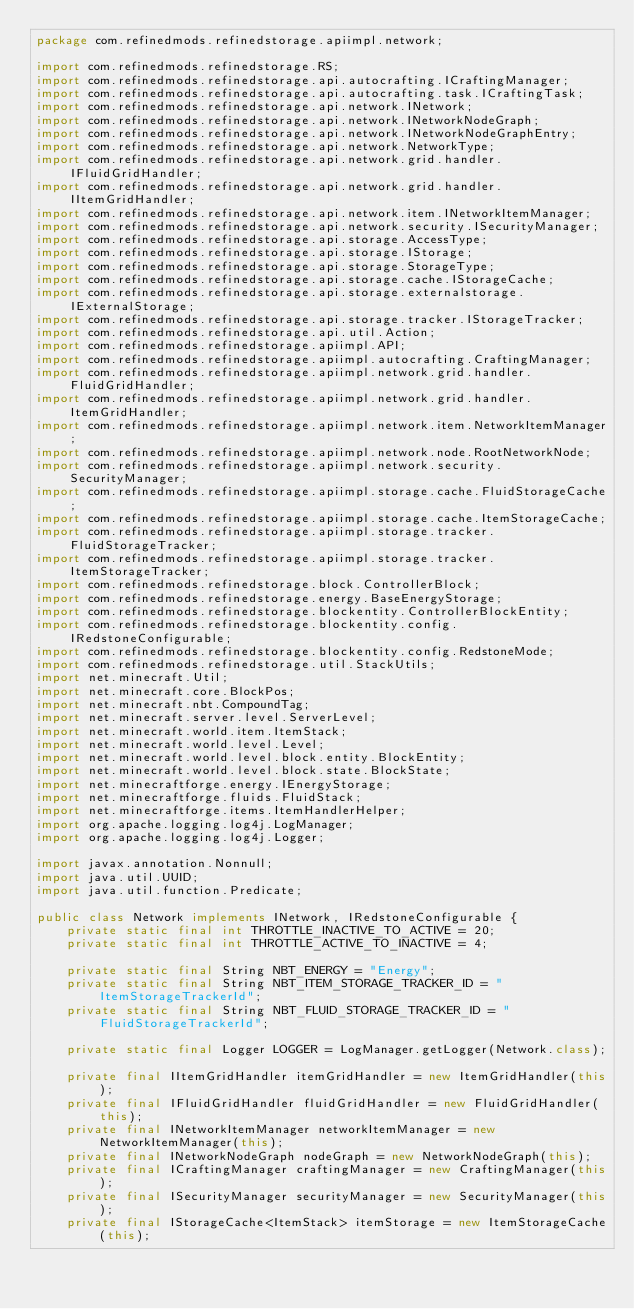<code> <loc_0><loc_0><loc_500><loc_500><_Java_>package com.refinedmods.refinedstorage.apiimpl.network;

import com.refinedmods.refinedstorage.RS;
import com.refinedmods.refinedstorage.api.autocrafting.ICraftingManager;
import com.refinedmods.refinedstorage.api.autocrafting.task.ICraftingTask;
import com.refinedmods.refinedstorage.api.network.INetwork;
import com.refinedmods.refinedstorage.api.network.INetworkNodeGraph;
import com.refinedmods.refinedstorage.api.network.INetworkNodeGraphEntry;
import com.refinedmods.refinedstorage.api.network.NetworkType;
import com.refinedmods.refinedstorage.api.network.grid.handler.IFluidGridHandler;
import com.refinedmods.refinedstorage.api.network.grid.handler.IItemGridHandler;
import com.refinedmods.refinedstorage.api.network.item.INetworkItemManager;
import com.refinedmods.refinedstorage.api.network.security.ISecurityManager;
import com.refinedmods.refinedstorage.api.storage.AccessType;
import com.refinedmods.refinedstorage.api.storage.IStorage;
import com.refinedmods.refinedstorage.api.storage.StorageType;
import com.refinedmods.refinedstorage.api.storage.cache.IStorageCache;
import com.refinedmods.refinedstorage.api.storage.externalstorage.IExternalStorage;
import com.refinedmods.refinedstorage.api.storage.tracker.IStorageTracker;
import com.refinedmods.refinedstorage.api.util.Action;
import com.refinedmods.refinedstorage.apiimpl.API;
import com.refinedmods.refinedstorage.apiimpl.autocrafting.CraftingManager;
import com.refinedmods.refinedstorage.apiimpl.network.grid.handler.FluidGridHandler;
import com.refinedmods.refinedstorage.apiimpl.network.grid.handler.ItemGridHandler;
import com.refinedmods.refinedstorage.apiimpl.network.item.NetworkItemManager;
import com.refinedmods.refinedstorage.apiimpl.network.node.RootNetworkNode;
import com.refinedmods.refinedstorage.apiimpl.network.security.SecurityManager;
import com.refinedmods.refinedstorage.apiimpl.storage.cache.FluidStorageCache;
import com.refinedmods.refinedstorage.apiimpl.storage.cache.ItemStorageCache;
import com.refinedmods.refinedstorage.apiimpl.storage.tracker.FluidStorageTracker;
import com.refinedmods.refinedstorage.apiimpl.storage.tracker.ItemStorageTracker;
import com.refinedmods.refinedstorage.block.ControllerBlock;
import com.refinedmods.refinedstorage.energy.BaseEnergyStorage;
import com.refinedmods.refinedstorage.blockentity.ControllerBlockEntity;
import com.refinedmods.refinedstorage.blockentity.config.IRedstoneConfigurable;
import com.refinedmods.refinedstorage.blockentity.config.RedstoneMode;
import com.refinedmods.refinedstorage.util.StackUtils;
import net.minecraft.Util;
import net.minecraft.core.BlockPos;
import net.minecraft.nbt.CompoundTag;
import net.minecraft.server.level.ServerLevel;
import net.minecraft.world.item.ItemStack;
import net.minecraft.world.level.Level;
import net.minecraft.world.level.block.entity.BlockEntity;
import net.minecraft.world.level.block.state.BlockState;
import net.minecraftforge.energy.IEnergyStorage;
import net.minecraftforge.fluids.FluidStack;
import net.minecraftforge.items.ItemHandlerHelper;
import org.apache.logging.log4j.LogManager;
import org.apache.logging.log4j.Logger;

import javax.annotation.Nonnull;
import java.util.UUID;
import java.util.function.Predicate;

public class Network implements INetwork, IRedstoneConfigurable {
    private static final int THROTTLE_INACTIVE_TO_ACTIVE = 20;
    private static final int THROTTLE_ACTIVE_TO_INACTIVE = 4;

    private static final String NBT_ENERGY = "Energy";
    private static final String NBT_ITEM_STORAGE_TRACKER_ID = "ItemStorageTrackerId";
    private static final String NBT_FLUID_STORAGE_TRACKER_ID = "FluidStorageTrackerId";

    private static final Logger LOGGER = LogManager.getLogger(Network.class);

    private final IItemGridHandler itemGridHandler = new ItemGridHandler(this);
    private final IFluidGridHandler fluidGridHandler = new FluidGridHandler(this);
    private final INetworkItemManager networkItemManager = new NetworkItemManager(this);
    private final INetworkNodeGraph nodeGraph = new NetworkNodeGraph(this);
    private final ICraftingManager craftingManager = new CraftingManager(this);
    private final ISecurityManager securityManager = new SecurityManager(this);
    private final IStorageCache<ItemStack> itemStorage = new ItemStorageCache(this);</code> 